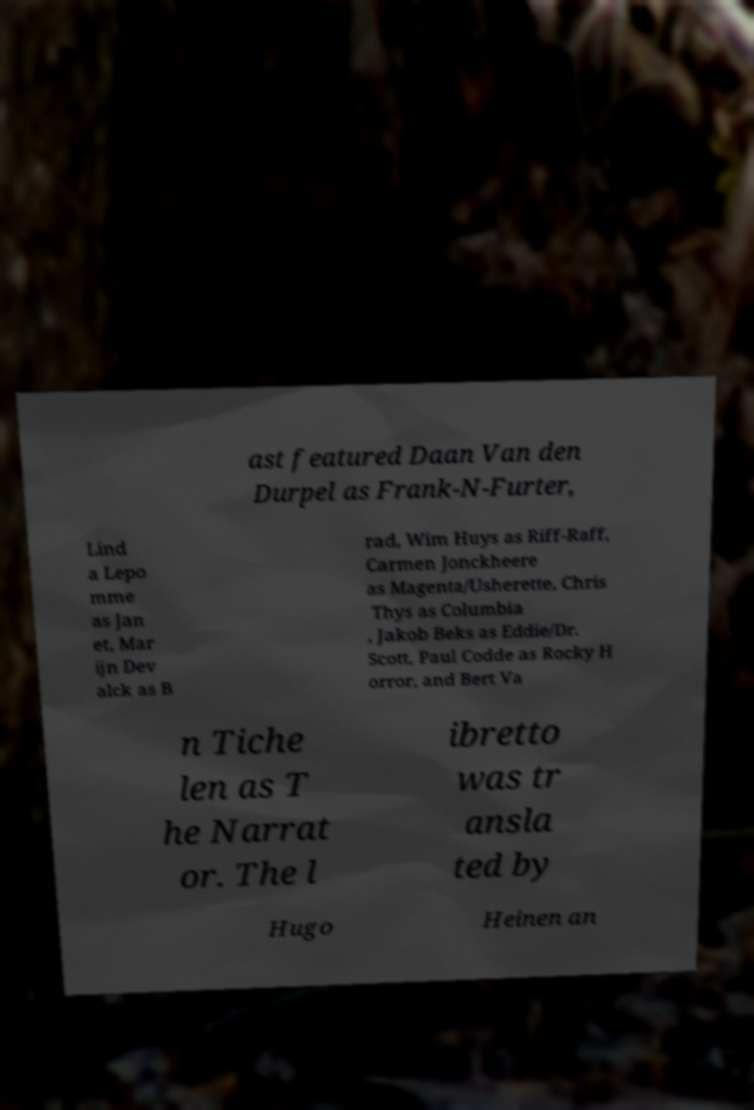Can you read and provide the text displayed in the image?This photo seems to have some interesting text. Can you extract and type it out for me? ast featured Daan Van den Durpel as Frank-N-Furter, Lind a Lepo mme as Jan et, Mar ijn Dev alck as B rad, Wim Huys as Riff-Raff, Carmen Jonckheere as Magenta/Usherette, Chris Thys as Columbia , Jakob Beks as Eddie/Dr. Scott, Paul Codde as Rocky H orror, and Bert Va n Tiche len as T he Narrat or. The l ibretto was tr ansla ted by Hugo Heinen an 